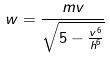Convert formula to latex. <formula><loc_0><loc_0><loc_500><loc_500>w = \frac { m v } { \sqrt { 5 - \frac { v ^ { 6 } } { h ^ { 6 } } } }</formula> 